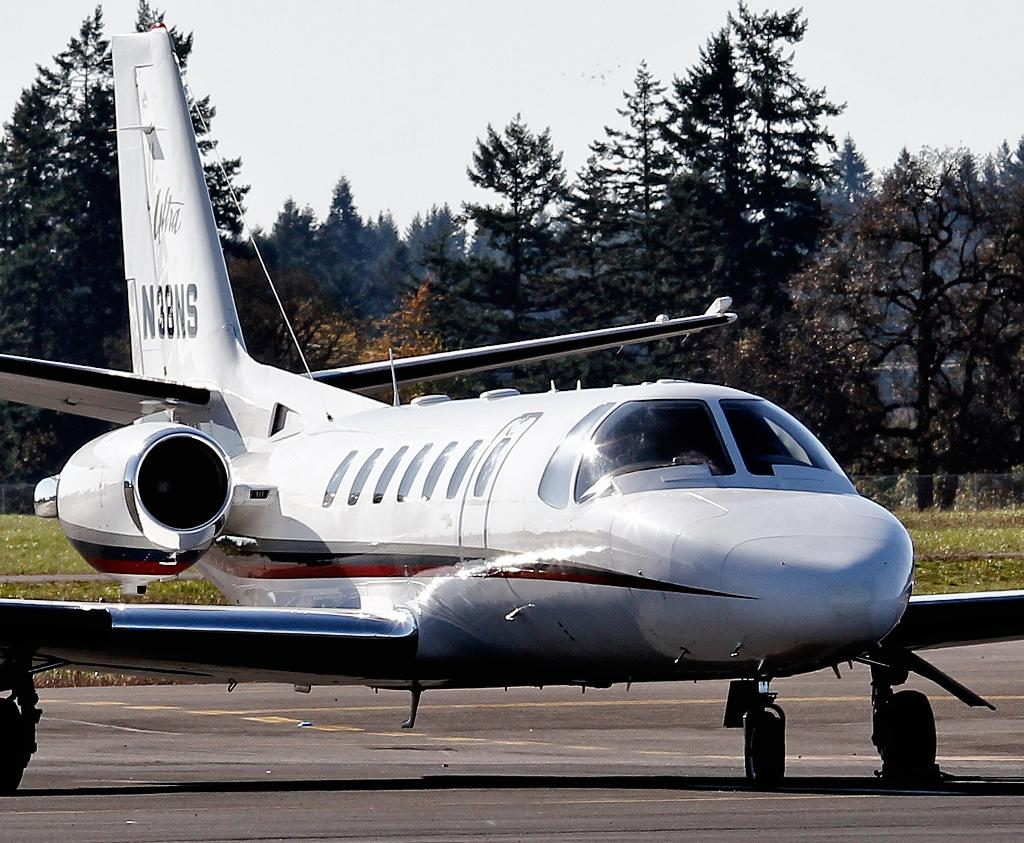<image>
Provide a brief description of the given image. n38ns airplace on a parking lot with trees all around on a fall day. 